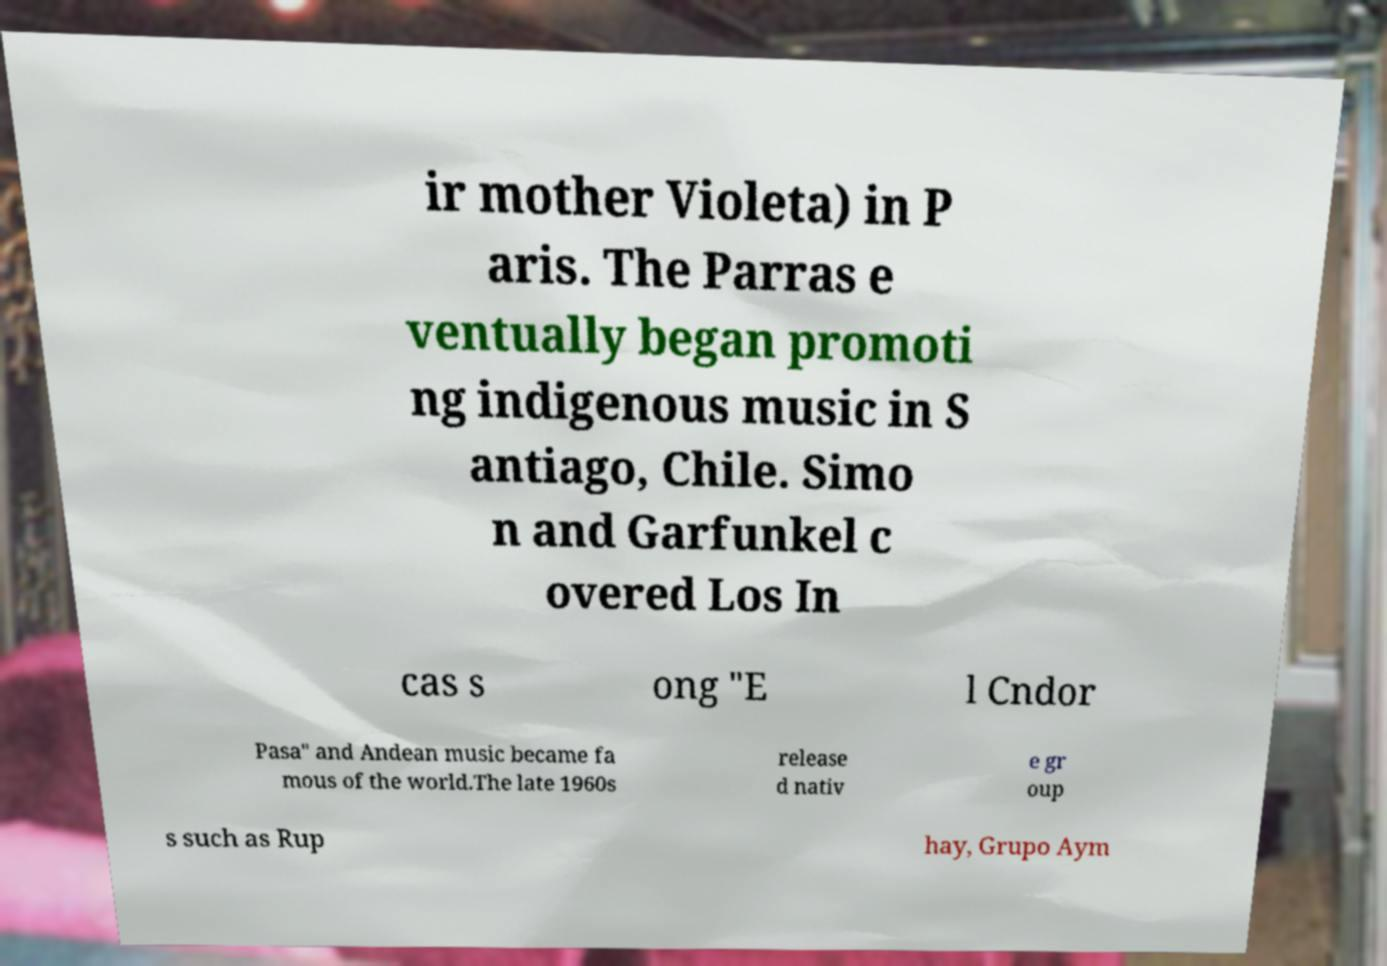Please identify and transcribe the text found in this image. ir mother Violeta) in P aris. The Parras e ventually began promoti ng indigenous music in S antiago, Chile. Simo n and Garfunkel c overed Los In cas s ong "E l Cndor Pasa" and Andean music became fa mous of the world.The late 1960s release d nativ e gr oup s such as Rup hay, Grupo Aym 